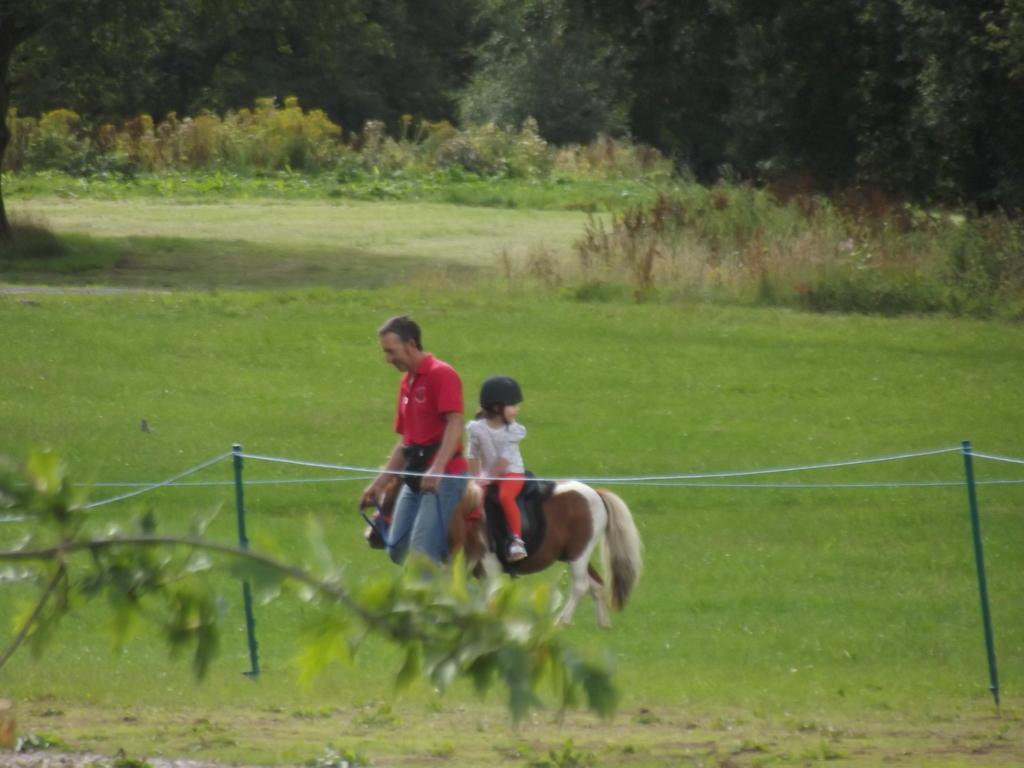What is the main subject of the image? There is a man in the image. What is the man doing in the image? The man is walking on the grassland. Are there any other people in the image? Yes, there is a girl in the image. What is the girl doing in the image? The girl is sitting on a horse. What type of guide is the man holding in the image? There is no guide visible in the image; the man is simply walking on the grassland. 